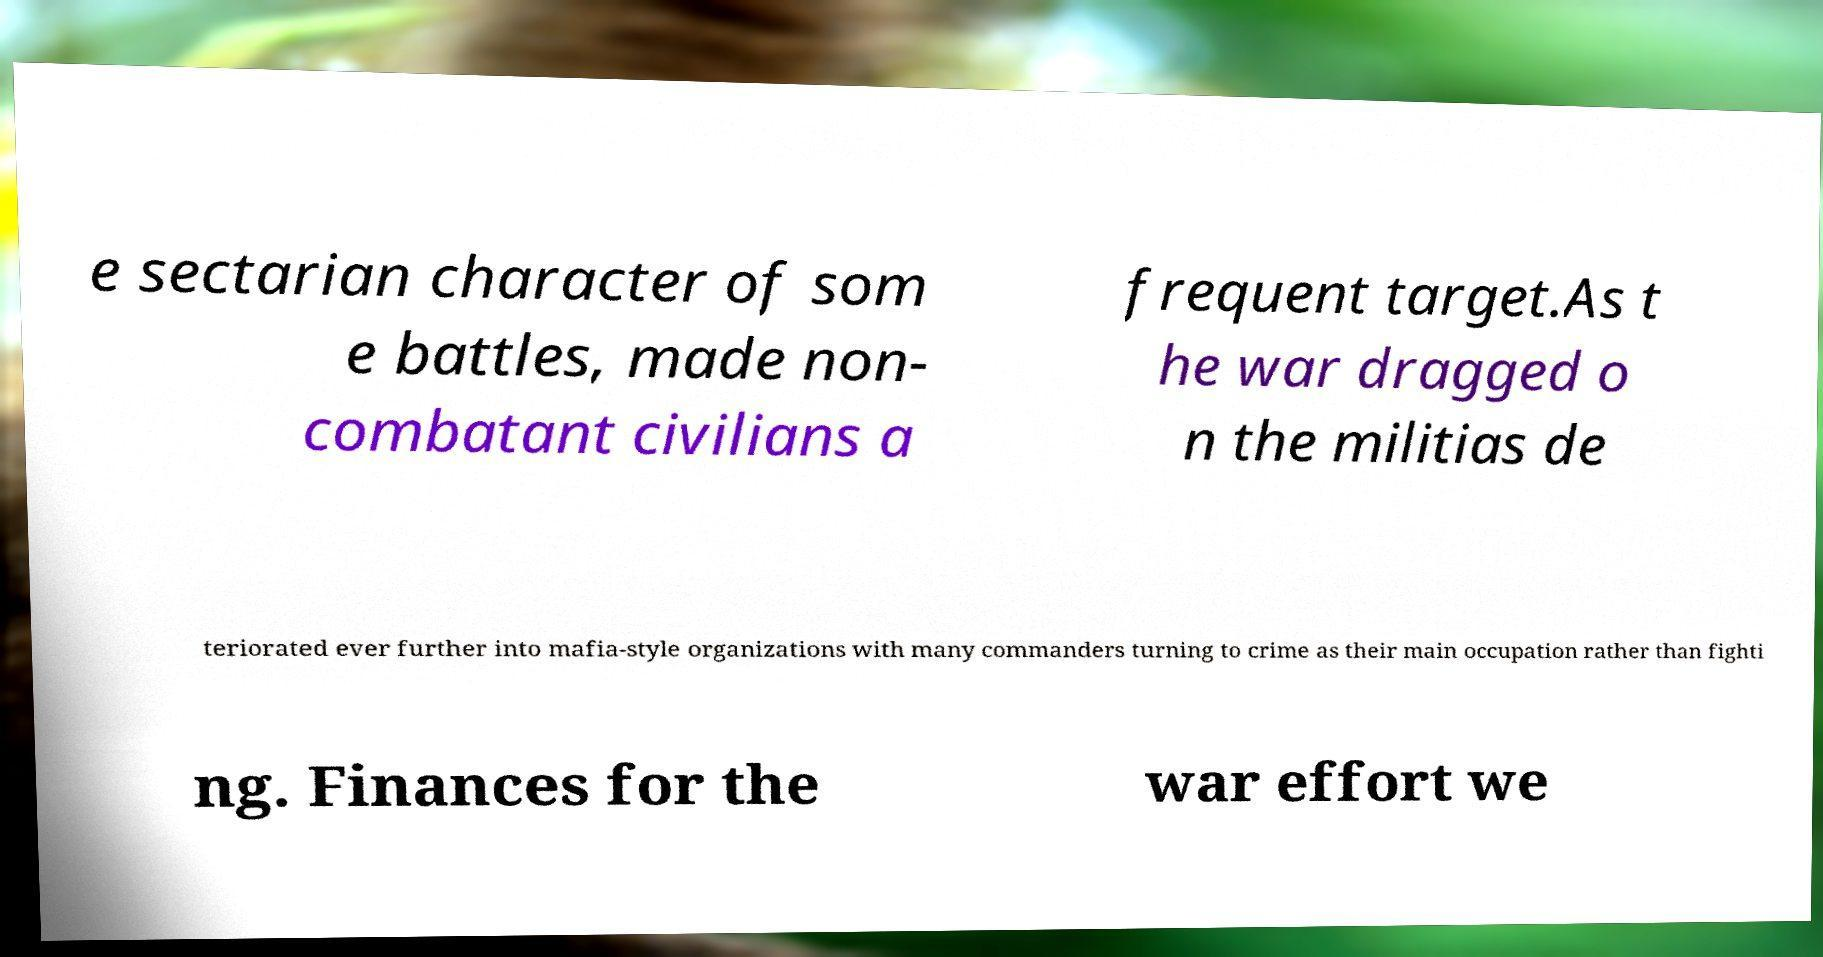What messages or text are displayed in this image? I need them in a readable, typed format. e sectarian character of som e battles, made non- combatant civilians a frequent target.As t he war dragged o n the militias de teriorated ever further into mafia-style organizations with many commanders turning to crime as their main occupation rather than fighti ng. Finances for the war effort we 